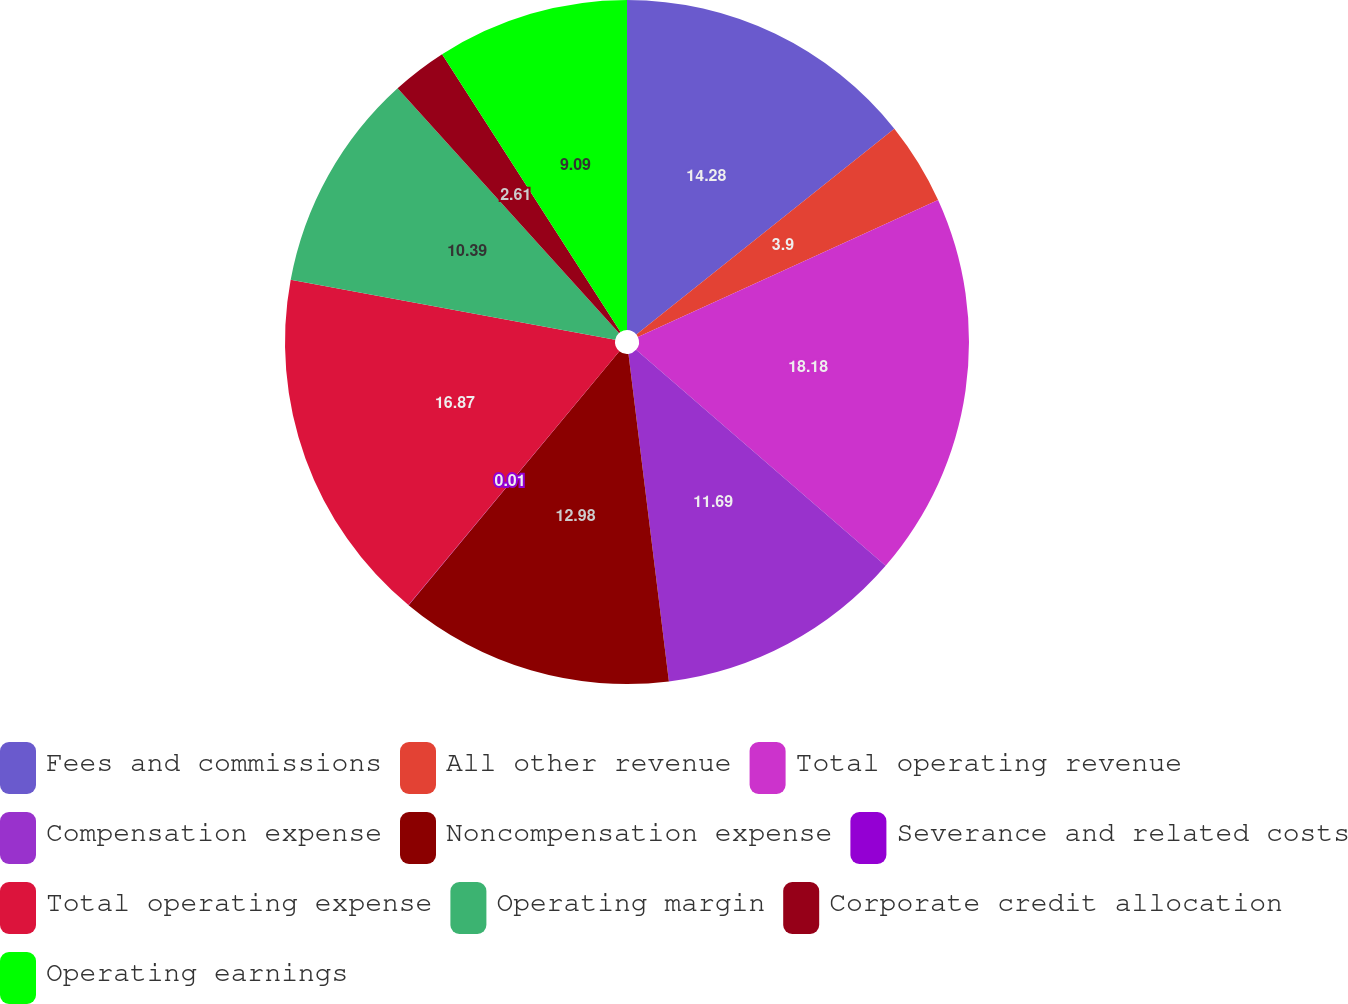<chart> <loc_0><loc_0><loc_500><loc_500><pie_chart><fcel>Fees and commissions<fcel>All other revenue<fcel>Total operating revenue<fcel>Compensation expense<fcel>Noncompensation expense<fcel>Severance and related costs<fcel>Total operating expense<fcel>Operating margin<fcel>Corporate credit allocation<fcel>Operating earnings<nl><fcel>14.28%<fcel>3.9%<fcel>18.17%<fcel>11.69%<fcel>12.98%<fcel>0.01%<fcel>16.87%<fcel>10.39%<fcel>2.61%<fcel>9.09%<nl></chart> 